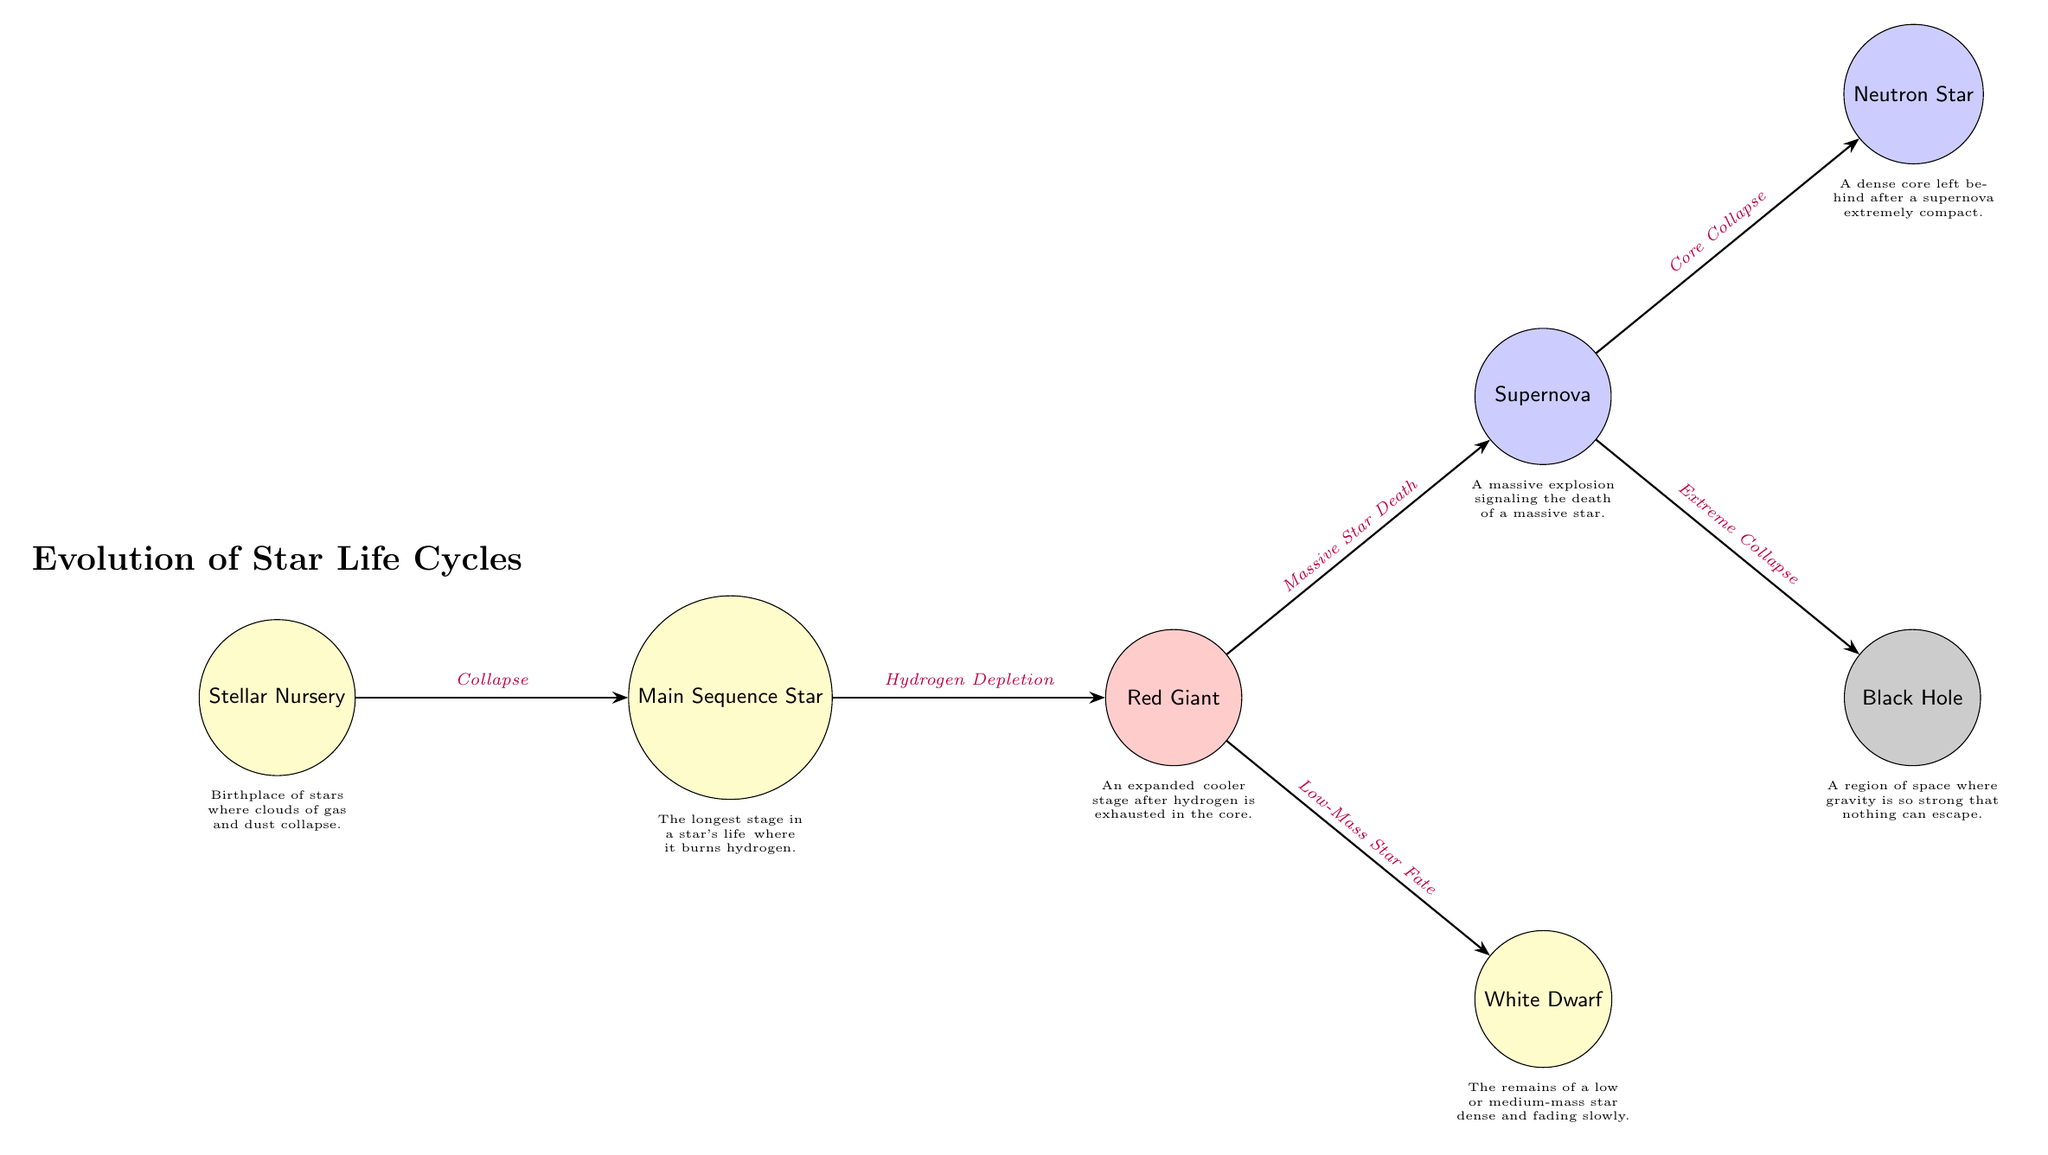What is the first stage in the star life cycle? The diagram identifies the "Stellar Nursery" as the first node, which represents the initial stage of star formation where gas and dust clouds begin to collapse.
Answer: Stellar Nursery How many types of end states are shown for stars in the diagram? There are three end states illustrated: "Neutron Star", "Black Hole", and "White Dwarf", representing the final outcomes for massive and low-mass stars.
Answer: Three What event leads to the formation of a Neutron Star? A Neutron Star is formed following the "Core Collapse" that occurs after a supernova, demonstrating a direct relationship between these two nodes in the diagram.
Answer: Core Collapse Which phase comes after a Red Giant in the life cycle? The diagram indicates the transition from "Red Giant" to "Supernova", marking a significant event in the life cycle of massive stars.
Answer: Supernova Which node describes the fate of low-mass stars after the Red Giant phase? The diagram specifies that the "Low-Mass Star Fate" leads to the "White Dwarf", indicating this outcome uniquely for stars that do not undergo a supernova.
Answer: White Dwarf What is the main sequence of a star focused on? The "Main Sequence Star" phase is primarily characterized by the burning of hydrogen, which is a crucial aspect of stellar evolution as described in the diagram.
Answer: Burning hydrogen What does a Black Hole signify in the life cycle of a star? A Black Hole represents a region of space formed after the "Extreme Collapse" following a supernova, highlighting the end of a massive star's life cycle.
Answer: Extreme Collapse What happens to a star during its "Hydrogen Depletion"? During "Hydrogen Depletion", a star transitions from being a "Main Sequence Star" to a "Red Giant", representing the depletion of its primary fuel for nuclear fusion.
Answer: Red Giant In what stage do stars typically spend the longest time? The "Main Sequence Star" stage is noted in the diagram as the longest phase for a star, indicating that it is a stable, prolonged period of stellar development.
Answer: Main Sequence Star 